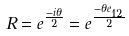<formula> <loc_0><loc_0><loc_500><loc_500>R = e ^ { \frac { - i \theta } { 2 } } = e ^ { \frac { - \theta e _ { 1 2 } } { 2 } }</formula> 